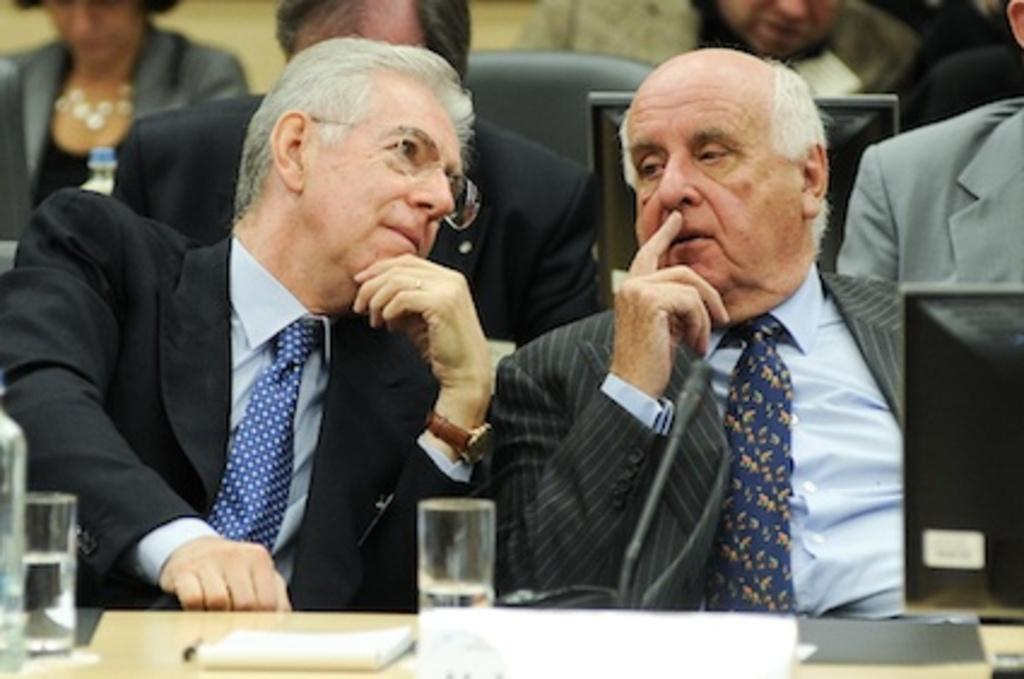How many people are in the image? There are two people in the image. What are the two people wearing? The two people are wearing suits. Where are the two people sitting? The two people are sitting in front of a table. What can be seen on the table? There are two glasses, a screen, and papers on the table. Are there any other people visible in the image? Yes, there are other people visible behind the two people. What type of chicken is being used as a light bulb in the image? There is no chicken or light bulb present in the image. 